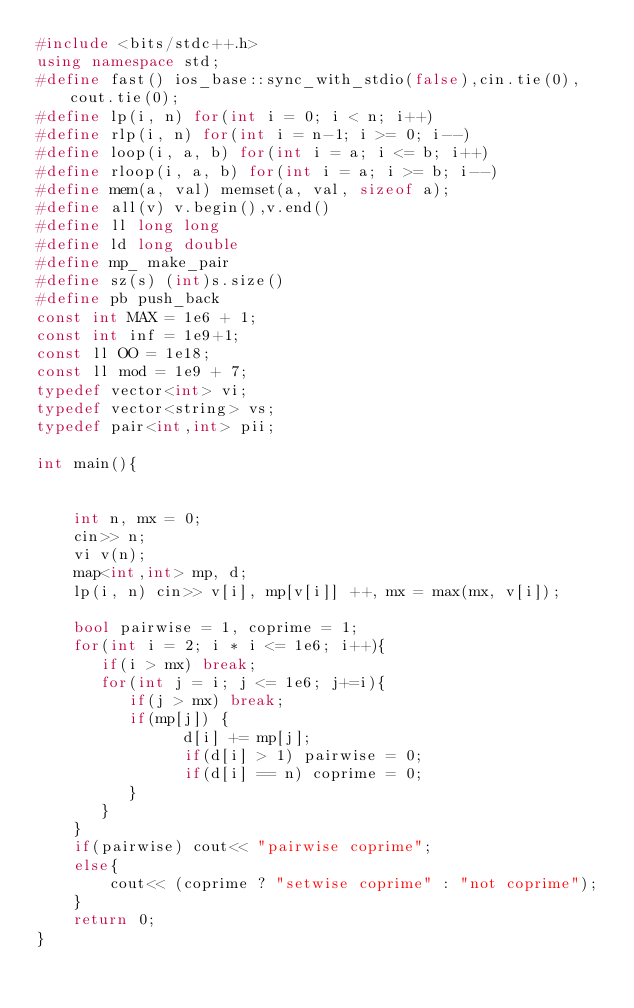<code> <loc_0><loc_0><loc_500><loc_500><_C++_>#include <bits/stdc++.h>
using namespace std;
#define fast() ios_base::sync_with_stdio(false),cin.tie(0),cout.tie(0);
#define lp(i, n) for(int i = 0; i < n; i++)
#define rlp(i, n) for(int i = n-1; i >= 0; i--)
#define loop(i, a, b) for(int i = a; i <= b; i++)
#define rloop(i, a, b) for(int i = a; i >= b; i--)
#define mem(a, val) memset(a, val, sizeof a);
#define all(v) v.begin(),v.end()
#define ll long long
#define ld long double
#define mp_ make_pair
#define sz(s) (int)s.size()
#define pb push_back
const int MAX = 1e6 + 1;
const int inf = 1e9+1;
const ll OO = 1e18;
const ll mod = 1e9 + 7;
typedef vector<int> vi;
typedef vector<string> vs;
typedef pair<int,int> pii;

int main(){


    int n, mx = 0;
    cin>> n;
    vi v(n);
    map<int,int> mp, d;
    lp(i, n) cin>> v[i], mp[v[i]] ++, mx = max(mx, v[i]);

    bool pairwise = 1, coprime = 1;
    for(int i = 2; i * i <= 1e6; i++){
       if(i > mx) break;
       for(int j = i; j <= 1e6; j+=i){
          if(j > mx) break;
          if(mp[j]) {
                d[i] += mp[j];
                if(d[i] > 1) pairwise = 0;
                if(d[i] == n) coprime = 0;
          }
       }
    }
    if(pairwise) cout<< "pairwise coprime";
    else{
        cout<< (coprime ? "setwise coprime" : "not coprime");
    }
    return 0;
}
</code> 